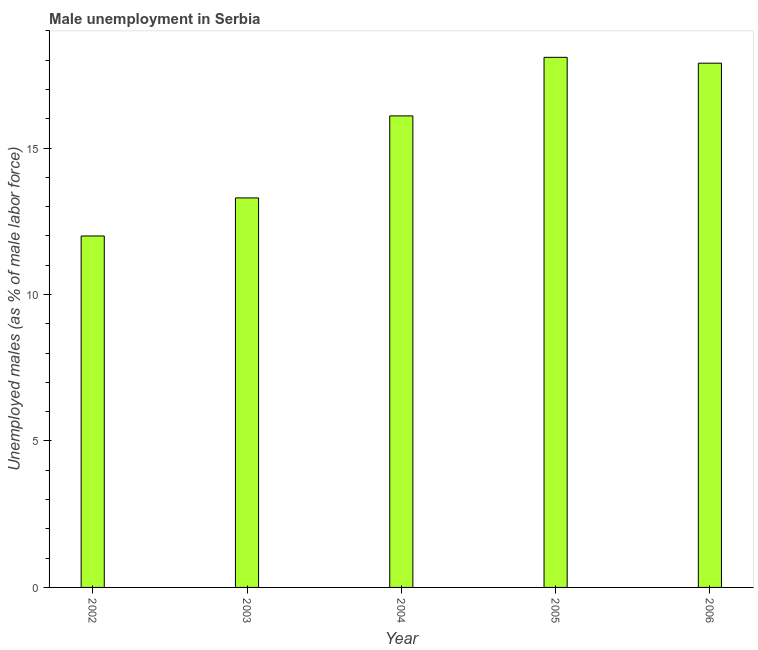Does the graph contain any zero values?
Make the answer very short. No. Does the graph contain grids?
Provide a short and direct response. No. What is the title of the graph?
Keep it short and to the point. Male unemployment in Serbia. What is the label or title of the X-axis?
Ensure brevity in your answer.  Year. What is the label or title of the Y-axis?
Provide a short and direct response. Unemployed males (as % of male labor force). Across all years, what is the maximum unemployed males population?
Provide a short and direct response. 18.1. What is the sum of the unemployed males population?
Your answer should be compact. 77.4. What is the average unemployed males population per year?
Your answer should be compact. 15.48. What is the median unemployed males population?
Give a very brief answer. 16.1. Do a majority of the years between 2002 and 2005 (inclusive) have unemployed males population greater than 13 %?
Keep it short and to the point. Yes. What is the ratio of the unemployed males population in 2003 to that in 2004?
Offer a very short reply. 0.83. Is the difference between the unemployed males population in 2003 and 2004 greater than the difference between any two years?
Make the answer very short. No. Is the sum of the unemployed males population in 2003 and 2006 greater than the maximum unemployed males population across all years?
Offer a terse response. Yes. What is the difference between the highest and the lowest unemployed males population?
Make the answer very short. 6.1. In how many years, is the unemployed males population greater than the average unemployed males population taken over all years?
Provide a succinct answer. 3. Are all the bars in the graph horizontal?
Offer a terse response. No. How many years are there in the graph?
Provide a succinct answer. 5. Are the values on the major ticks of Y-axis written in scientific E-notation?
Keep it short and to the point. No. What is the Unemployed males (as % of male labor force) of 2003?
Make the answer very short. 13.3. What is the Unemployed males (as % of male labor force) in 2004?
Offer a very short reply. 16.1. What is the Unemployed males (as % of male labor force) of 2005?
Ensure brevity in your answer.  18.1. What is the Unemployed males (as % of male labor force) of 2006?
Make the answer very short. 17.9. What is the difference between the Unemployed males (as % of male labor force) in 2002 and 2004?
Your answer should be very brief. -4.1. What is the difference between the Unemployed males (as % of male labor force) in 2002 and 2006?
Provide a short and direct response. -5.9. What is the difference between the Unemployed males (as % of male labor force) in 2003 and 2004?
Your answer should be very brief. -2.8. What is the ratio of the Unemployed males (as % of male labor force) in 2002 to that in 2003?
Your response must be concise. 0.9. What is the ratio of the Unemployed males (as % of male labor force) in 2002 to that in 2004?
Provide a short and direct response. 0.74. What is the ratio of the Unemployed males (as % of male labor force) in 2002 to that in 2005?
Your answer should be compact. 0.66. What is the ratio of the Unemployed males (as % of male labor force) in 2002 to that in 2006?
Provide a succinct answer. 0.67. What is the ratio of the Unemployed males (as % of male labor force) in 2003 to that in 2004?
Your answer should be compact. 0.83. What is the ratio of the Unemployed males (as % of male labor force) in 2003 to that in 2005?
Your answer should be compact. 0.73. What is the ratio of the Unemployed males (as % of male labor force) in 2003 to that in 2006?
Make the answer very short. 0.74. What is the ratio of the Unemployed males (as % of male labor force) in 2004 to that in 2005?
Your response must be concise. 0.89. What is the ratio of the Unemployed males (as % of male labor force) in 2004 to that in 2006?
Your answer should be very brief. 0.9. 